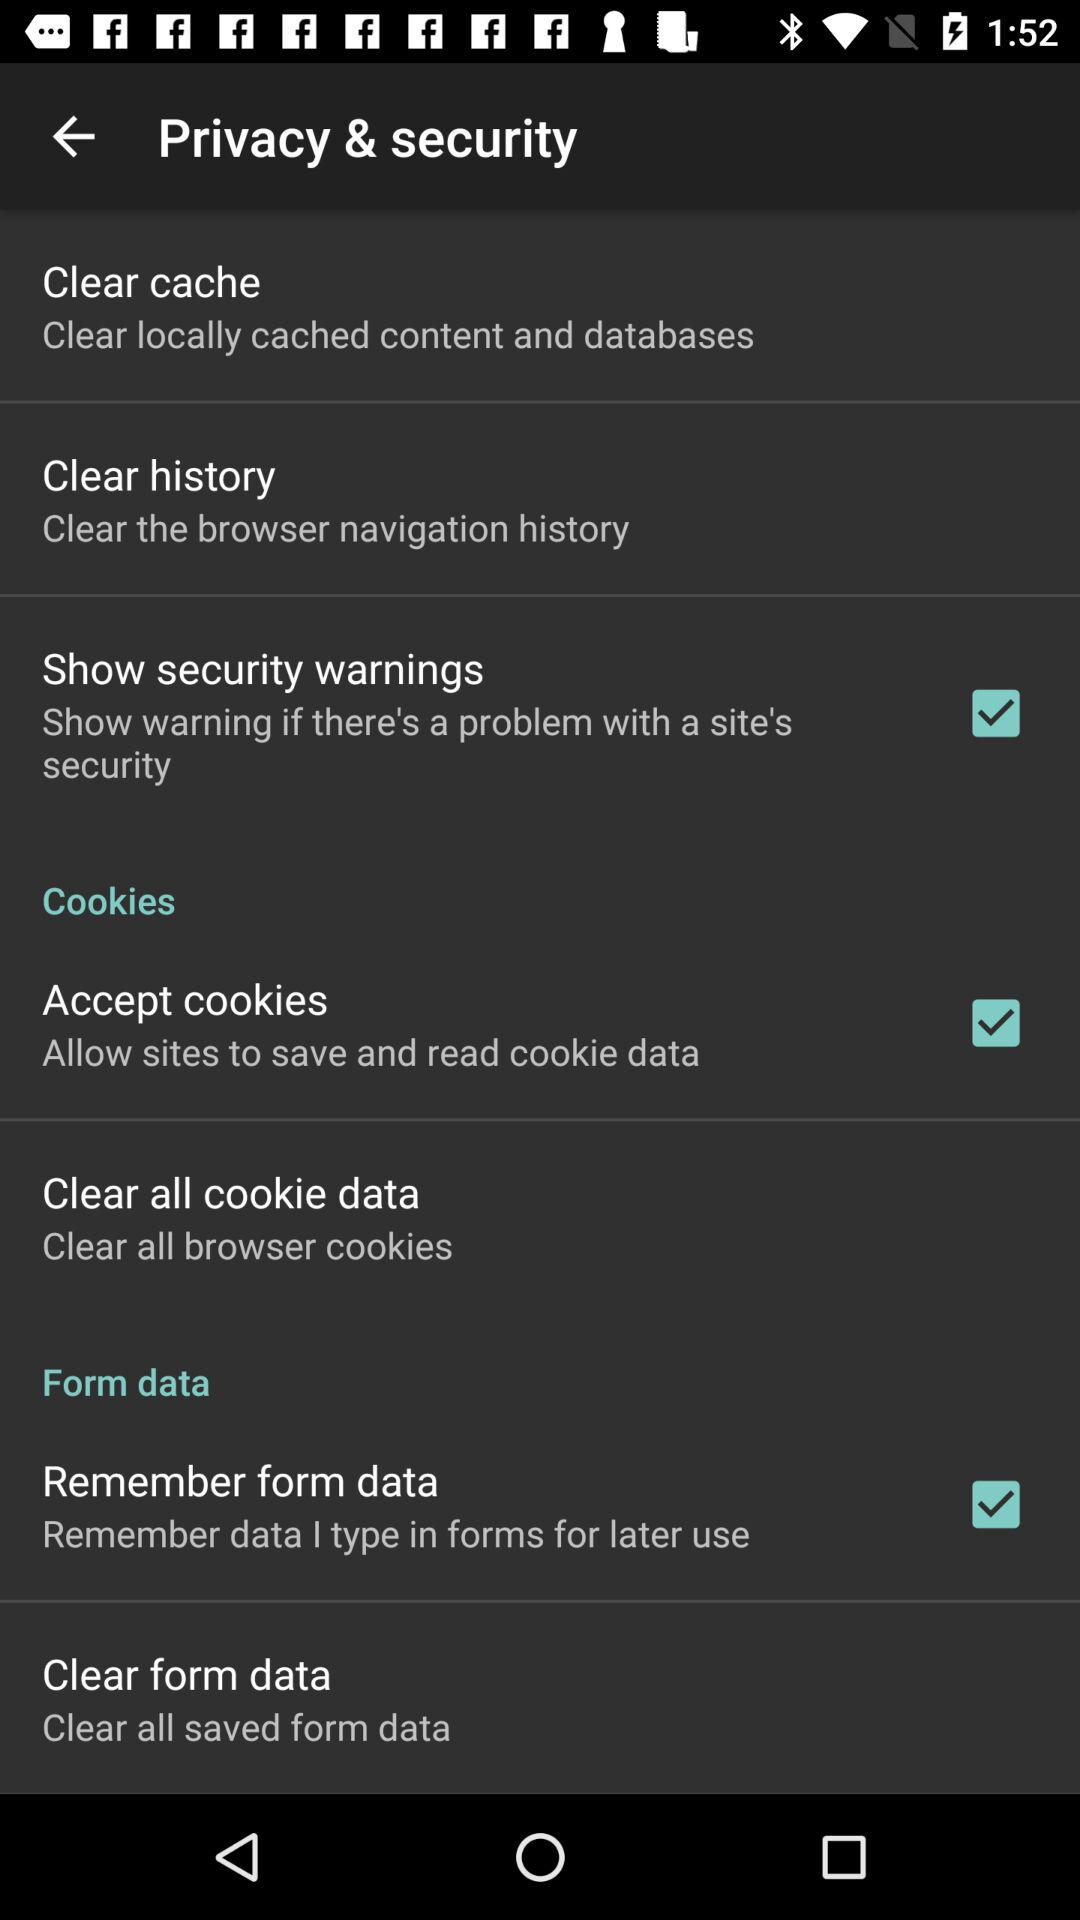What is the status of "Accept cookies"? The status is "on". 